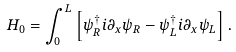<formula> <loc_0><loc_0><loc_500><loc_500>H _ { 0 } = \int _ { 0 } ^ { L } \left [ \psi _ { R } ^ { \dagger } i \partial _ { x } \psi _ { R } - \psi _ { L } ^ { \dagger } i \partial _ { x } \psi _ { L } \right ] .</formula> 